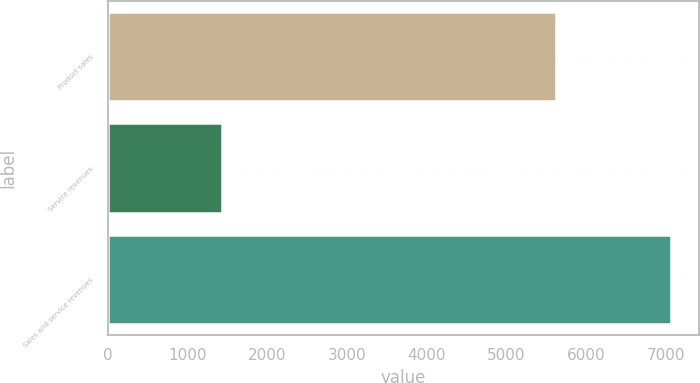Convert chart. <chart><loc_0><loc_0><loc_500><loc_500><bar_chart><fcel>Product sales<fcel>Service revenues<fcel>Sales and service revenues<nl><fcel>5631<fcel>1437<fcel>7068<nl></chart> 